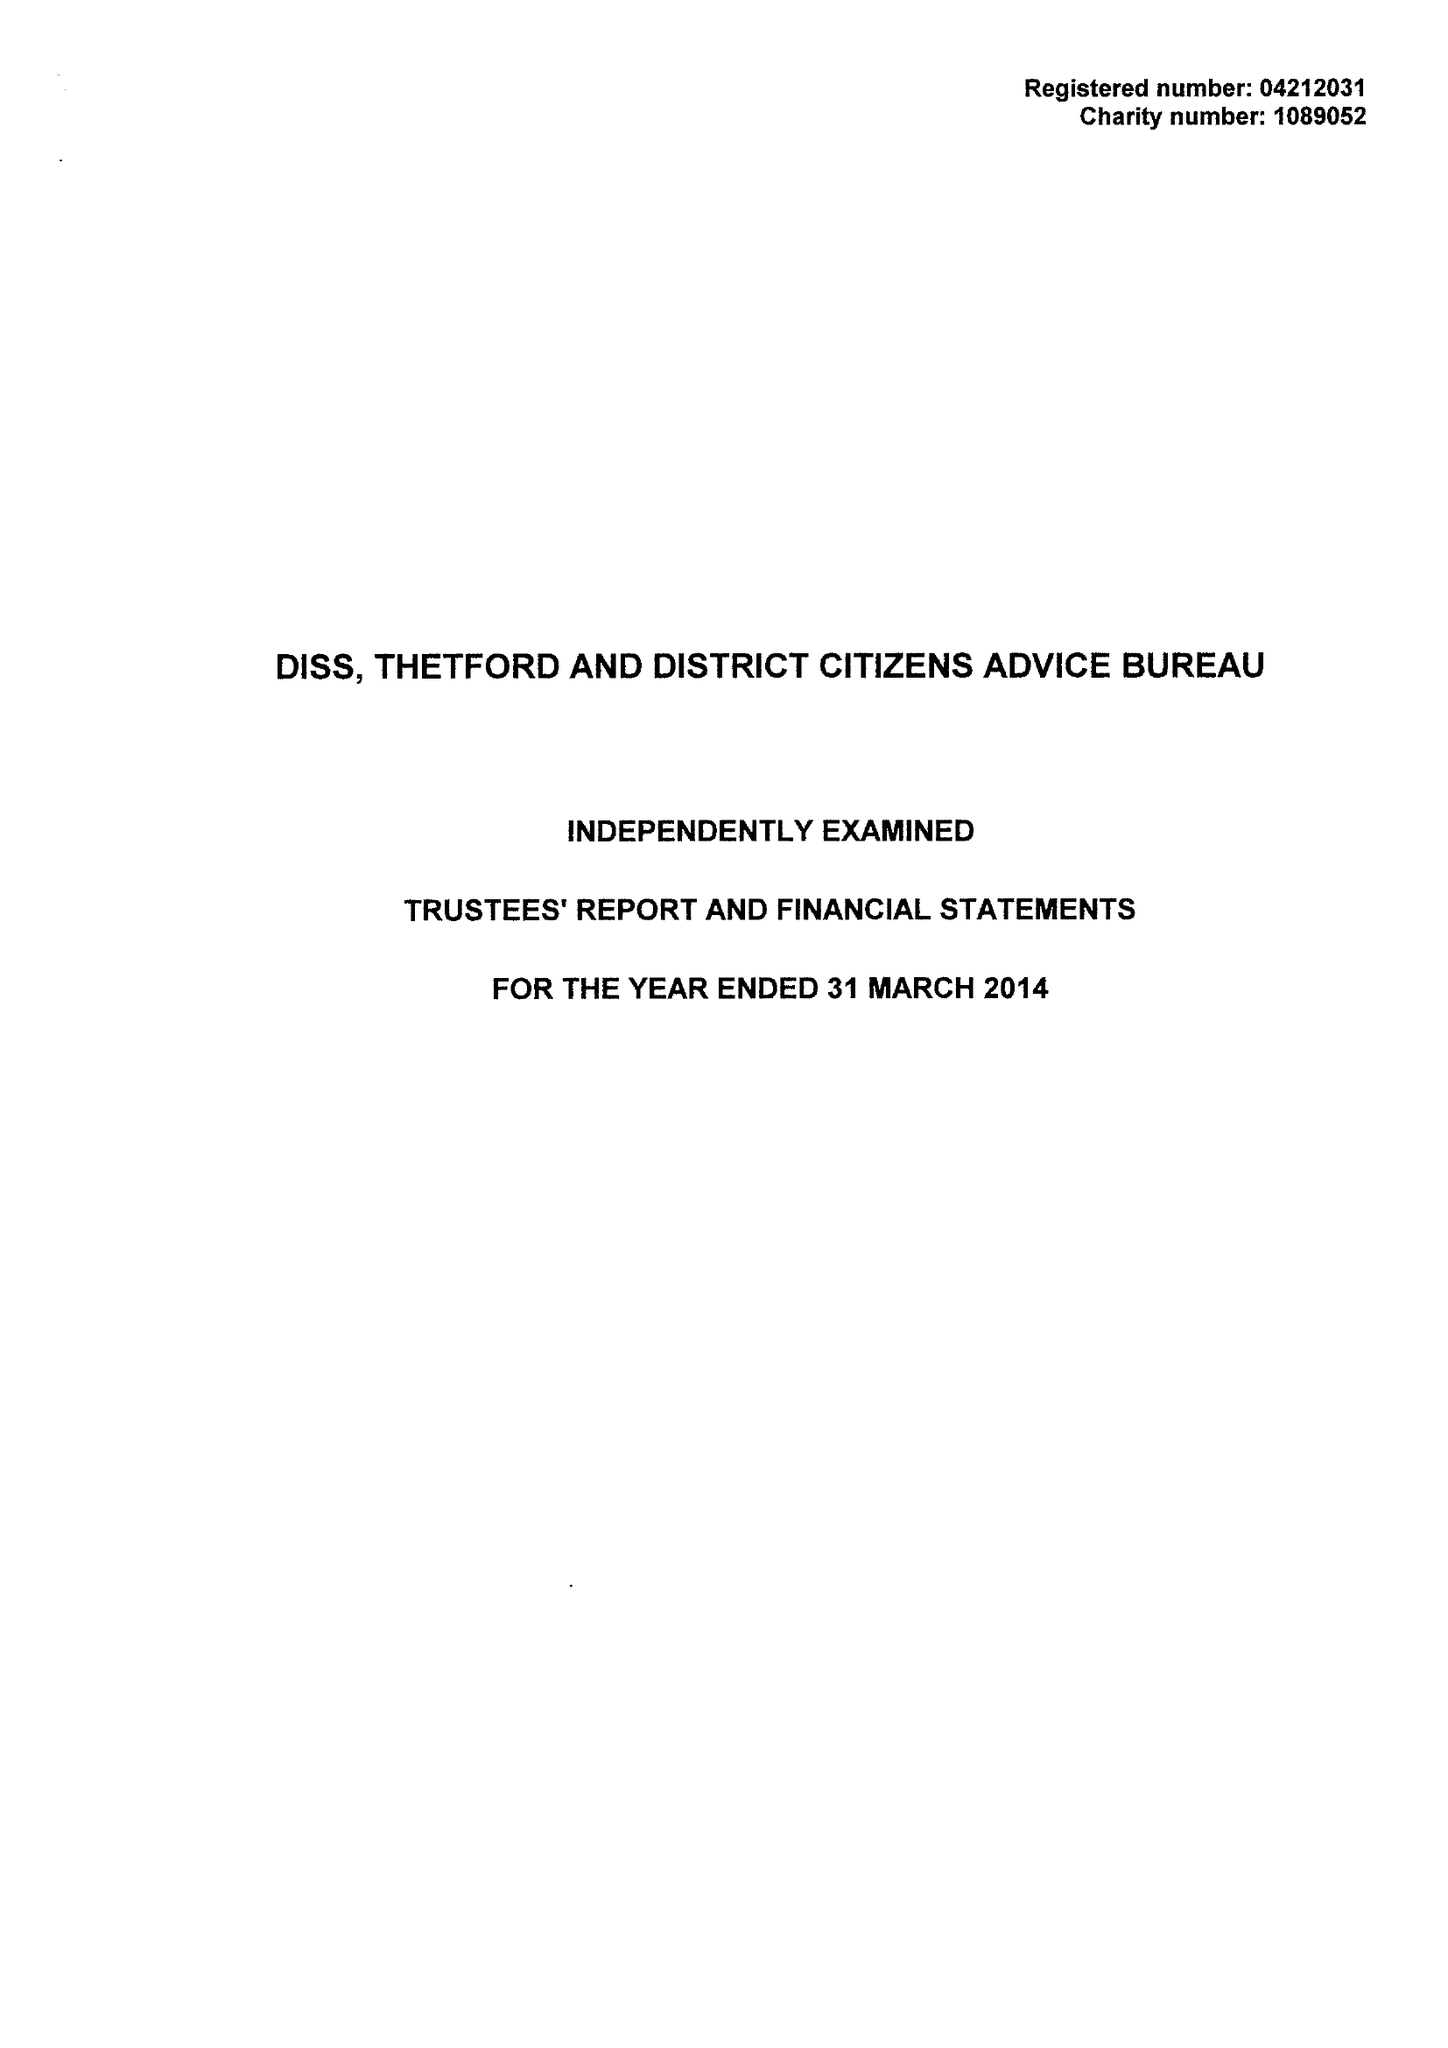What is the value for the report_date?
Answer the question using a single word or phrase. 2014-03-31 